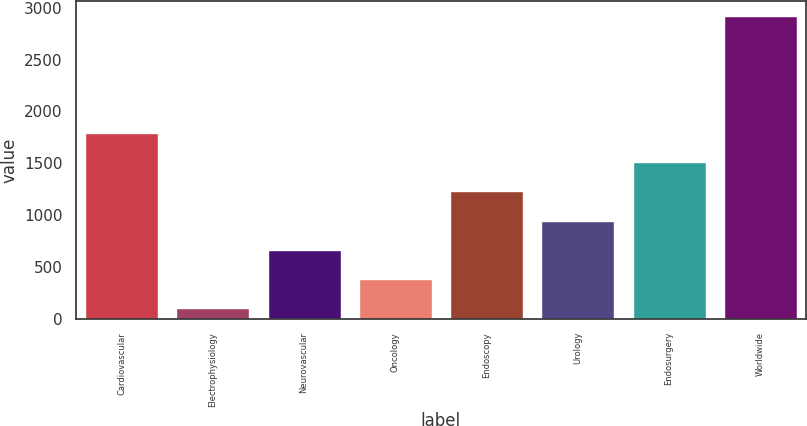Convert chart. <chart><loc_0><loc_0><loc_500><loc_500><bar_chart><fcel>Cardiovascular<fcel>Electrophysiology<fcel>Neurovascular<fcel>Oncology<fcel>Endoscopy<fcel>Urology<fcel>Endosurgery<fcel>Worldwide<nl><fcel>1797<fcel>101<fcel>664.6<fcel>382.8<fcel>1228.2<fcel>946.4<fcel>1510<fcel>2919<nl></chart> 